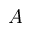<formula> <loc_0><loc_0><loc_500><loc_500>A</formula> 